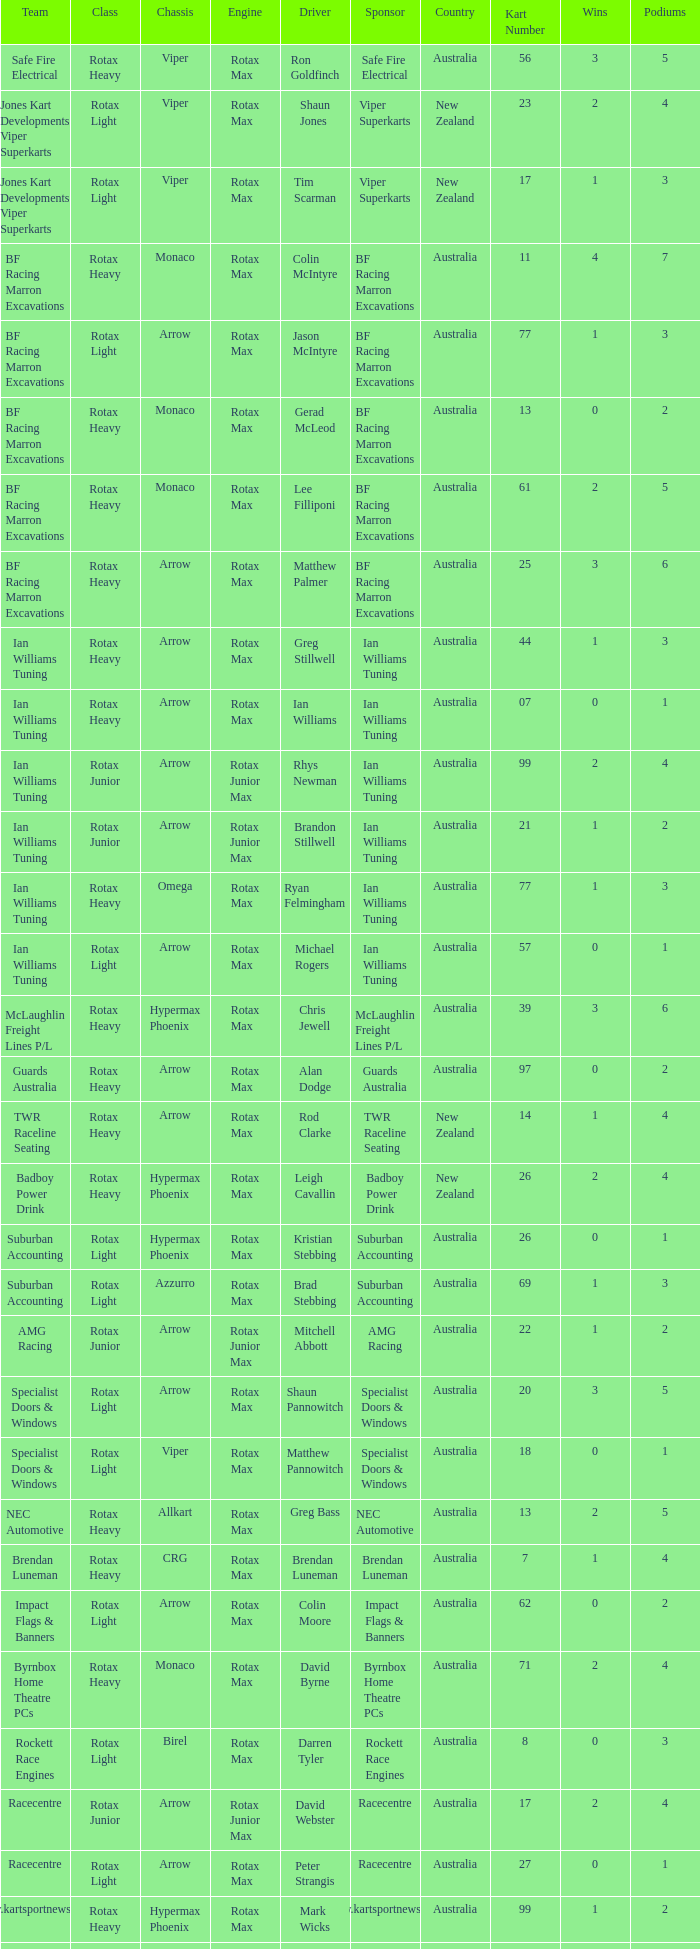I'm looking to parse the entire table for insights. Could you assist me with that? {'header': ['Team', 'Class', 'Chassis', 'Engine', 'Driver', 'Sponsor', 'Country', 'Kart Number', 'Wins', 'Podiums'], 'rows': [['Safe Fire Electrical', 'Rotax Heavy', 'Viper', 'Rotax Max', 'Ron Goldfinch', 'Safe Fire Electrical', 'Australia', '56', '3', '5'], ['Jones Kart Developments Viper Superkarts', 'Rotax Light', 'Viper', 'Rotax Max', 'Shaun Jones', 'Viper Superkarts', 'New Zealand', '23', '2', '4'], ['Jones Kart Developments Viper Superkarts', 'Rotax Light', 'Viper', 'Rotax Max', 'Tim Scarman', 'Viper Superkarts', 'New Zealand', '17', '1', '3'], ['BF Racing Marron Excavations', 'Rotax Heavy', 'Monaco', 'Rotax Max', 'Colin McIntyre', 'BF Racing Marron Excavations', 'Australia', '11', '4', '7'], ['BF Racing Marron Excavations', 'Rotax Light', 'Arrow', 'Rotax Max', 'Jason McIntyre', 'BF Racing Marron Excavations', 'Australia', '77', '1', '3'], ['BF Racing Marron Excavations', 'Rotax Heavy', 'Monaco', 'Rotax Max', 'Gerad McLeod', 'BF Racing Marron Excavations', 'Australia', '13', '0', '2'], ['BF Racing Marron Excavations', 'Rotax Heavy', 'Monaco', 'Rotax Max', 'Lee Filliponi', 'BF Racing Marron Excavations', 'Australia', '61', '2', '5'], ['BF Racing Marron Excavations', 'Rotax Heavy', 'Arrow', 'Rotax Max', 'Matthew Palmer', 'BF Racing Marron Excavations', 'Australia', '25', '3', '6'], ['Ian Williams Tuning', 'Rotax Heavy', 'Arrow', 'Rotax Max', 'Greg Stillwell', 'Ian Williams Tuning', 'Australia', '44', '1', '3'], ['Ian Williams Tuning', 'Rotax Heavy', 'Arrow', 'Rotax Max', 'Ian Williams', 'Ian Williams Tuning', 'Australia', '07', '0', '1'], ['Ian Williams Tuning', 'Rotax Junior', 'Arrow', 'Rotax Junior Max', 'Rhys Newman', 'Ian Williams Tuning', 'Australia', '99', '2', '4'], ['Ian Williams Tuning', 'Rotax Junior', 'Arrow', 'Rotax Junior Max', 'Brandon Stillwell', 'Ian Williams Tuning', 'Australia', '21', '1', '2'], ['Ian Williams Tuning', 'Rotax Heavy', 'Omega', 'Rotax Max', 'Ryan Felmingham', 'Ian Williams Tuning', 'Australia', '77', '1', '3'], ['Ian Williams Tuning', 'Rotax Light', 'Arrow', 'Rotax Max', 'Michael Rogers', 'Ian Williams Tuning', 'Australia', '57', '0', '1'], ['McLaughlin Freight Lines P/L', 'Rotax Heavy', 'Hypermax Phoenix', 'Rotax Max', 'Chris Jewell', 'McLaughlin Freight Lines P/L', 'Australia', '39', '3', '6'], ['Guards Australia', 'Rotax Heavy', 'Arrow', 'Rotax Max', 'Alan Dodge', 'Guards Australia', 'Australia', '97', '0', '2'], ['TWR Raceline Seating', 'Rotax Heavy', 'Arrow', 'Rotax Max', 'Rod Clarke', 'TWR Raceline Seating', 'New Zealand', '14', '1', '4'], ['Badboy Power Drink', 'Rotax Heavy', 'Hypermax Phoenix', 'Rotax Max', 'Leigh Cavallin', 'Badboy Power Drink', 'New Zealand', '26', '2', '4'], ['Suburban Accounting', 'Rotax Light', 'Hypermax Phoenix', 'Rotax Max', 'Kristian Stebbing', 'Suburban Accounting', 'Australia', '26', '0', '1'], ['Suburban Accounting', 'Rotax Light', 'Azzurro', 'Rotax Max', 'Brad Stebbing', 'Suburban Accounting', 'Australia', '69', '1', '3'], ['AMG Racing', 'Rotax Junior', 'Arrow', 'Rotax Junior Max', 'Mitchell Abbott', 'AMG Racing', 'Australia', '22', '1', '2'], ['Specialist Doors & Windows', 'Rotax Light', 'Arrow', 'Rotax Max', 'Shaun Pannowitch', 'Specialist Doors & Windows', 'Australia', '20', '3', '5'], ['Specialist Doors & Windows', 'Rotax Light', 'Viper', 'Rotax Max', 'Matthew Pannowitch', 'Specialist Doors & Windows', 'Australia', '18', '0', '1'], ['NEC Automotive', 'Rotax Heavy', 'Allkart', 'Rotax Max', 'Greg Bass', 'NEC Automotive', 'Australia', '13', '2', '5'], ['Brendan Luneman', 'Rotax Heavy', 'CRG', 'Rotax Max', 'Brendan Luneman', 'Brendan Luneman', 'Australia', '7', '1', '4'], ['Impact Flags & Banners', 'Rotax Light', 'Arrow', 'Rotax Max', 'Colin Moore', 'Impact Flags & Banners', 'Australia', '62', '0', '2'], ['Byrnbox Home Theatre PCs', 'Rotax Heavy', 'Monaco', 'Rotax Max', 'David Byrne', 'Byrnbox Home Theatre PCs', 'Australia', '71', '2', '4'], ['Rockett Race Engines', 'Rotax Light', 'Birel', 'Rotax Max', 'Darren Tyler', 'Rockett Race Engines', 'Australia', '8', '0', '3'], ['Racecentre', 'Rotax Junior', 'Arrow', 'Rotax Junior Max', 'David Webster', 'Racecentre', 'Australia', '17', '2', '4'], ['Racecentre', 'Rotax Light', 'Arrow', 'Rotax Max', 'Peter Strangis', 'Racecentre', 'Australia', '27', '0', '1'], ['www.kartsportnews.com', 'Rotax Heavy', 'Hypermax Phoenix', 'Rotax Max', 'Mark Wicks', 'www.kartsportnews.com', 'Australia', '99', '1', '2'], ['Doug Savage', 'Rotax Light', 'Arrow', 'Rotax Max', 'Doug Savage', 'Doug Savage', 'New Zealand', '41', '0', '1'], ['Race Stickerz Toyota Material Handling', 'Rotax Heavy', 'Techno', 'Rotax Max', 'Scott Appledore', 'Race Stickerz Toyota Material Handling', 'Australia', '27', '3', '6'], ['Wild Digital', 'Rotax Junior', 'Hypermax Phoenix', 'Rotax Junior Max', 'Sean Whitfield', 'Wild Digital', 'New Zealand', '15', '2', '4'], ['John Bartlett', 'Rotax Heavy', 'Hypermax Phoenix', 'Rotax Max', 'John Bartlett', 'John Bartlett', 'Australia', '91', '1', '2']]} Which team does Colin Moore drive for? Impact Flags & Banners. 